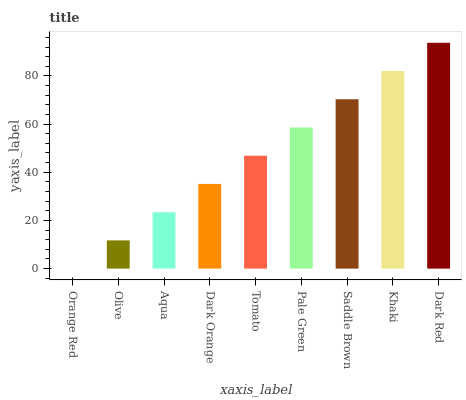Is Orange Red the minimum?
Answer yes or no. Yes. Is Dark Red the maximum?
Answer yes or no. Yes. Is Olive the minimum?
Answer yes or no. No. Is Olive the maximum?
Answer yes or no. No. Is Olive greater than Orange Red?
Answer yes or no. Yes. Is Orange Red less than Olive?
Answer yes or no. Yes. Is Orange Red greater than Olive?
Answer yes or no. No. Is Olive less than Orange Red?
Answer yes or no. No. Is Tomato the high median?
Answer yes or no. Yes. Is Tomato the low median?
Answer yes or no. Yes. Is Khaki the high median?
Answer yes or no. No. Is Saddle Brown the low median?
Answer yes or no. No. 